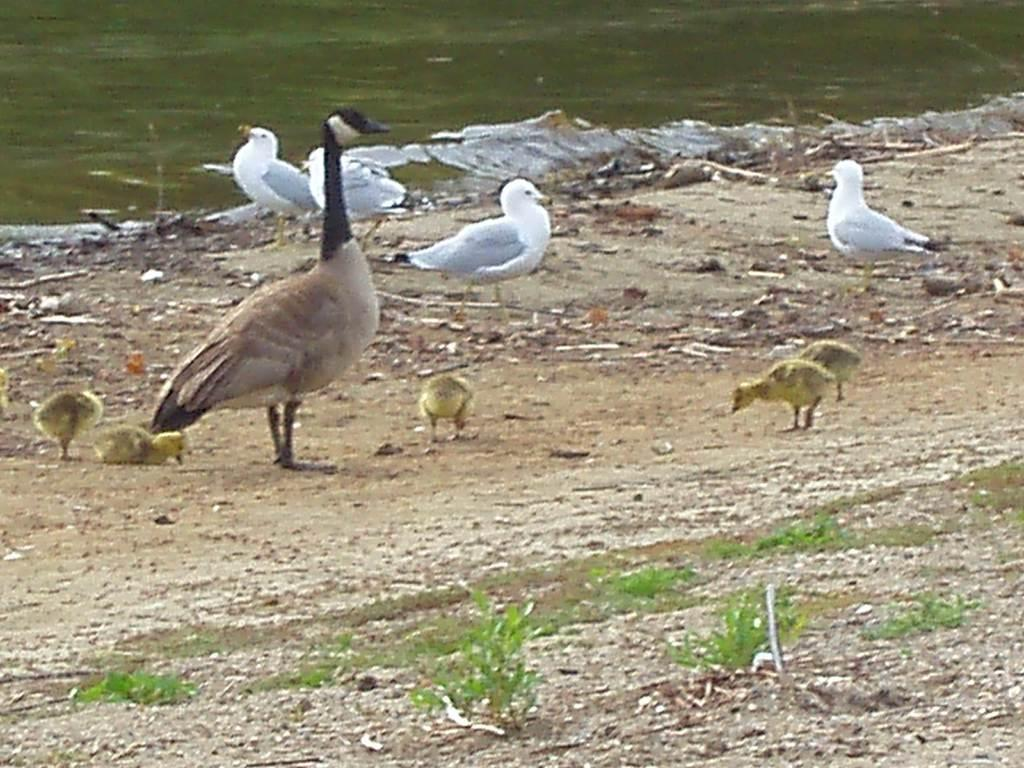What is located in the center of the image? There are birds in the center of the image. What type of terrain is visible at the bottom of the image? There is sand and grass at the bottom of the image. What can be seen in the background of the image? There is a lake visible in the background of the image. How many potatoes are being used as an attraction for the birds in the image? There are no potatoes present in the image, and the birds are not being attracted to any specific objects. 